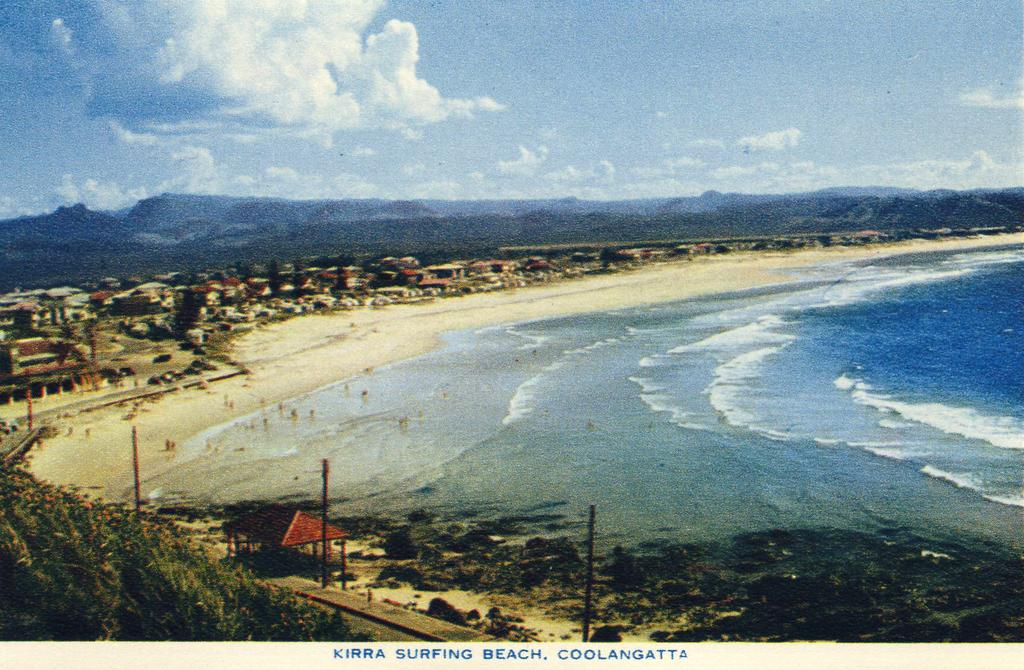What is the primary element present in the image? There is water in the image. What type of structures can be seen in the image? There are homes in the image. What natural feature is visible in the image? There are mountains in the image. What is visible at the top of the image? The sky is visible at the top of the image. Where is the brick located in the image? There is no brick present in the image. What type of lunchroom can be seen in the image? There is no lunchroom present in the image. 